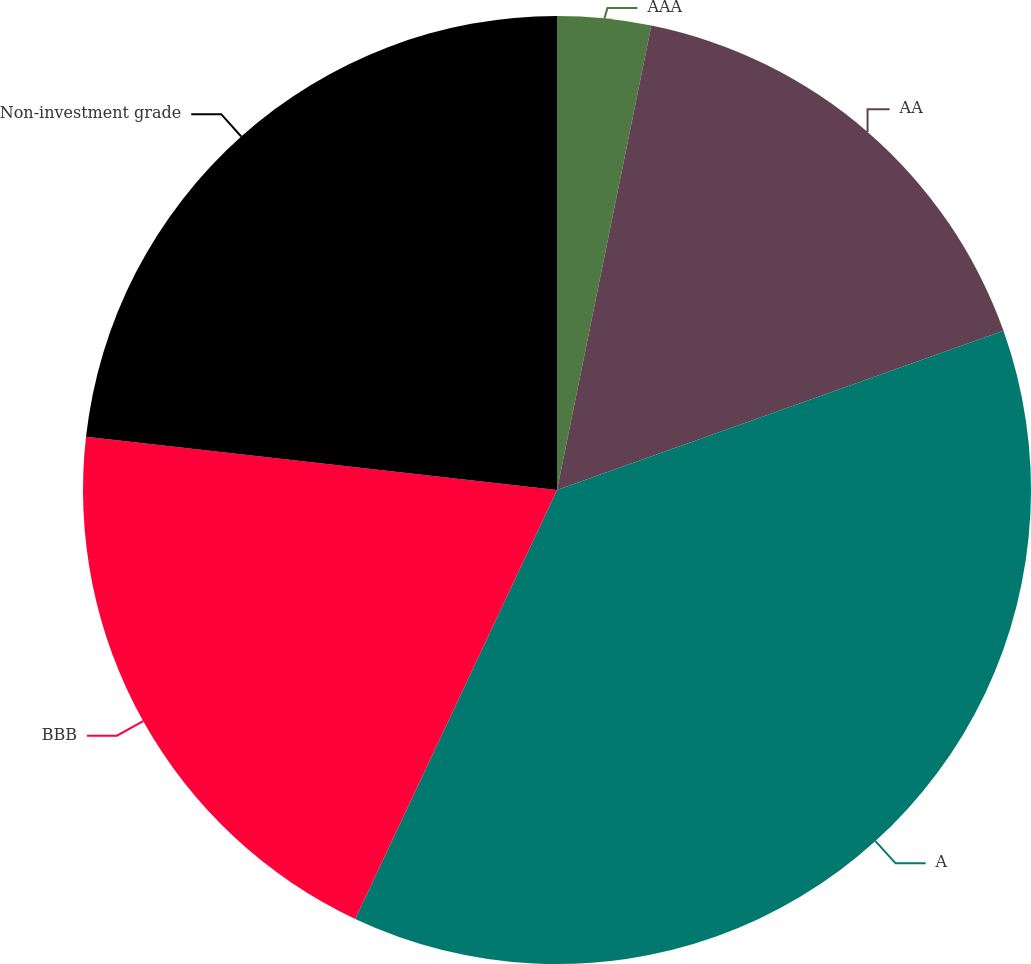Convert chart. <chart><loc_0><loc_0><loc_500><loc_500><pie_chart><fcel>AAA<fcel>AA<fcel>A<fcel>BBB<fcel>Non-investment grade<nl><fcel>3.19%<fcel>16.36%<fcel>37.45%<fcel>19.79%<fcel>23.21%<nl></chart> 